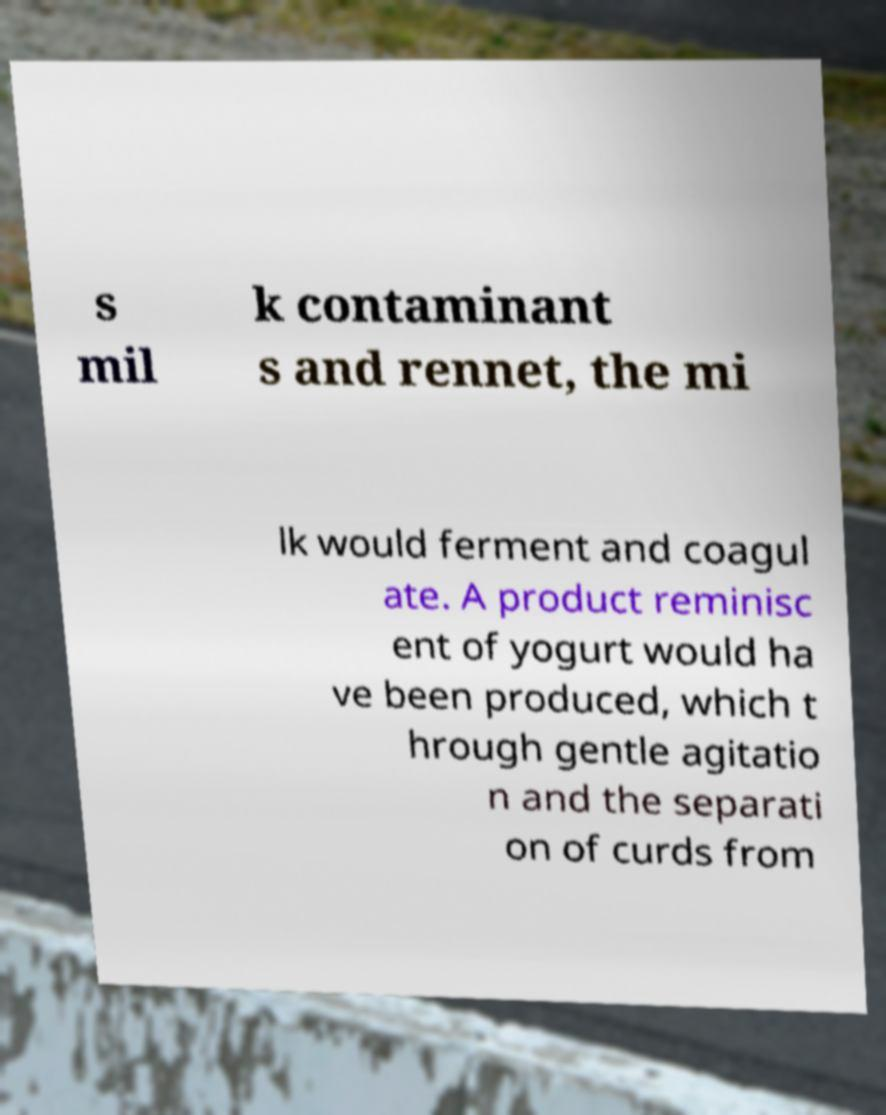What messages or text are displayed in this image? I need them in a readable, typed format. s mil k contaminant s and rennet, the mi lk would ferment and coagul ate. A product reminisc ent of yogurt would ha ve been produced, which t hrough gentle agitatio n and the separati on of curds from 